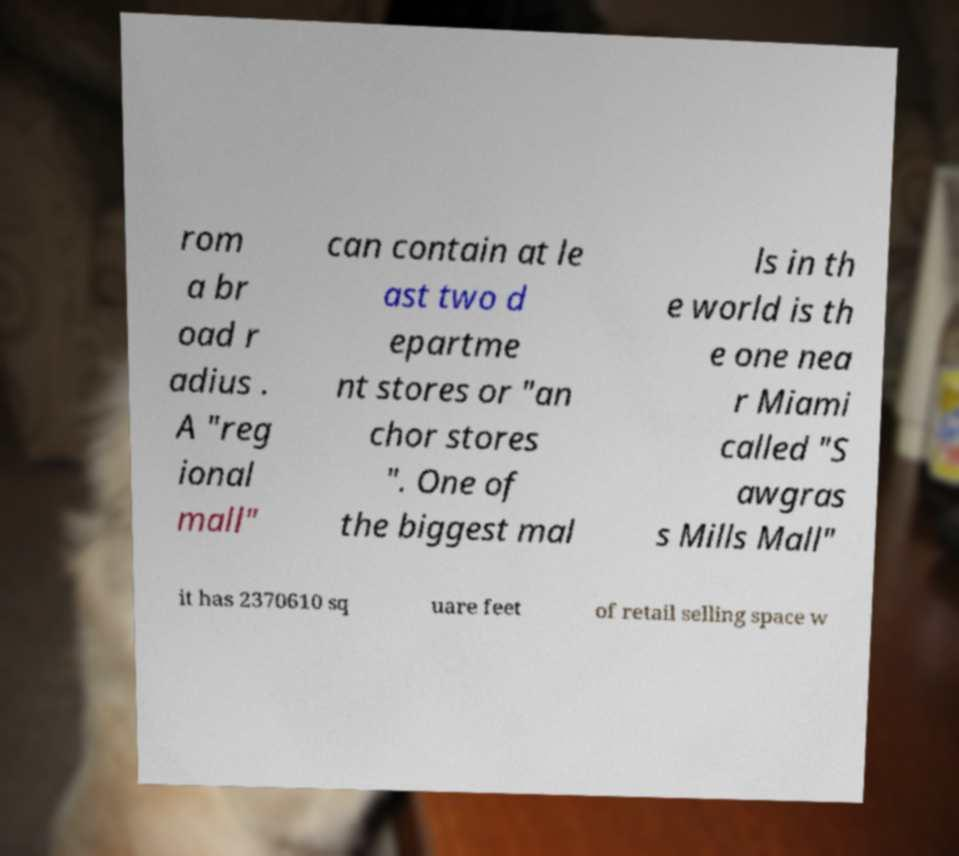Please read and relay the text visible in this image. What does it say? rom a br oad r adius . A "reg ional mall" can contain at le ast two d epartme nt stores or "an chor stores ". One of the biggest mal ls in th e world is th e one nea r Miami called "S awgras s Mills Mall" it has 2370610 sq uare feet of retail selling space w 